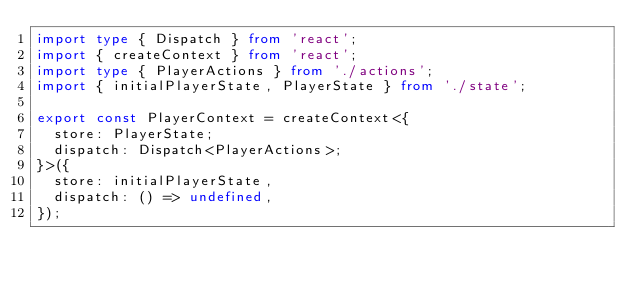Convert code to text. <code><loc_0><loc_0><loc_500><loc_500><_TypeScript_>import type { Dispatch } from 'react';
import { createContext } from 'react';
import type { PlayerActions } from './actions';
import { initialPlayerState, PlayerState } from './state';

export const PlayerContext = createContext<{
  store: PlayerState;
  dispatch: Dispatch<PlayerActions>;
}>({
  store: initialPlayerState,
  dispatch: () => undefined,
});
</code> 